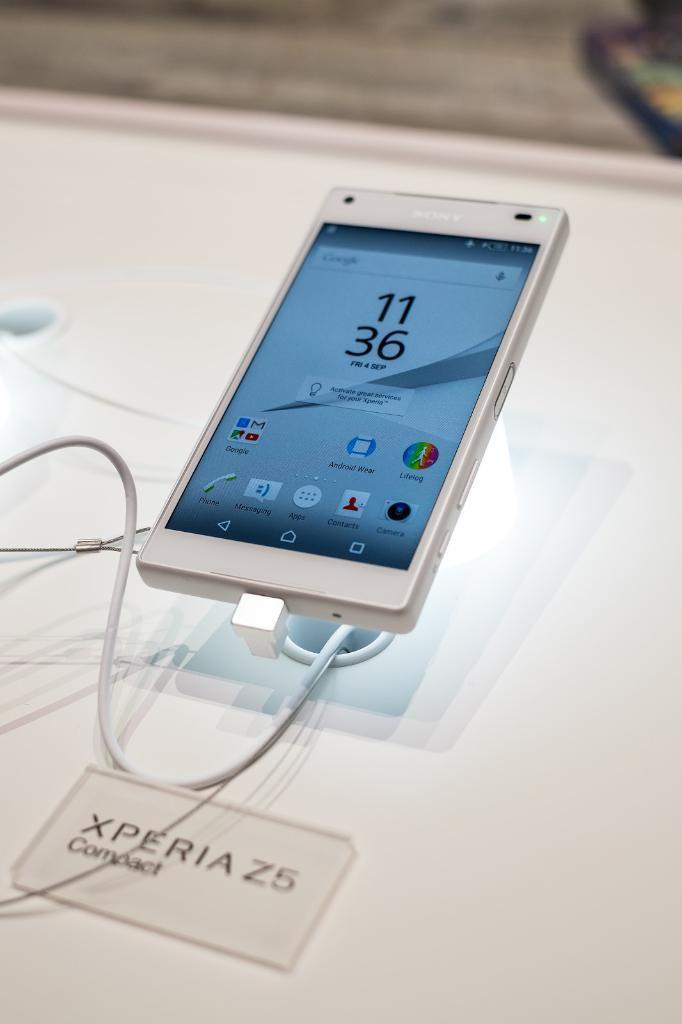Please provide a concise description of this image. Here in this picture we can see a mobile phone present on a stand, which is present on a table and we can also see cable wire connected to it and in front of it we can see a name card present. 